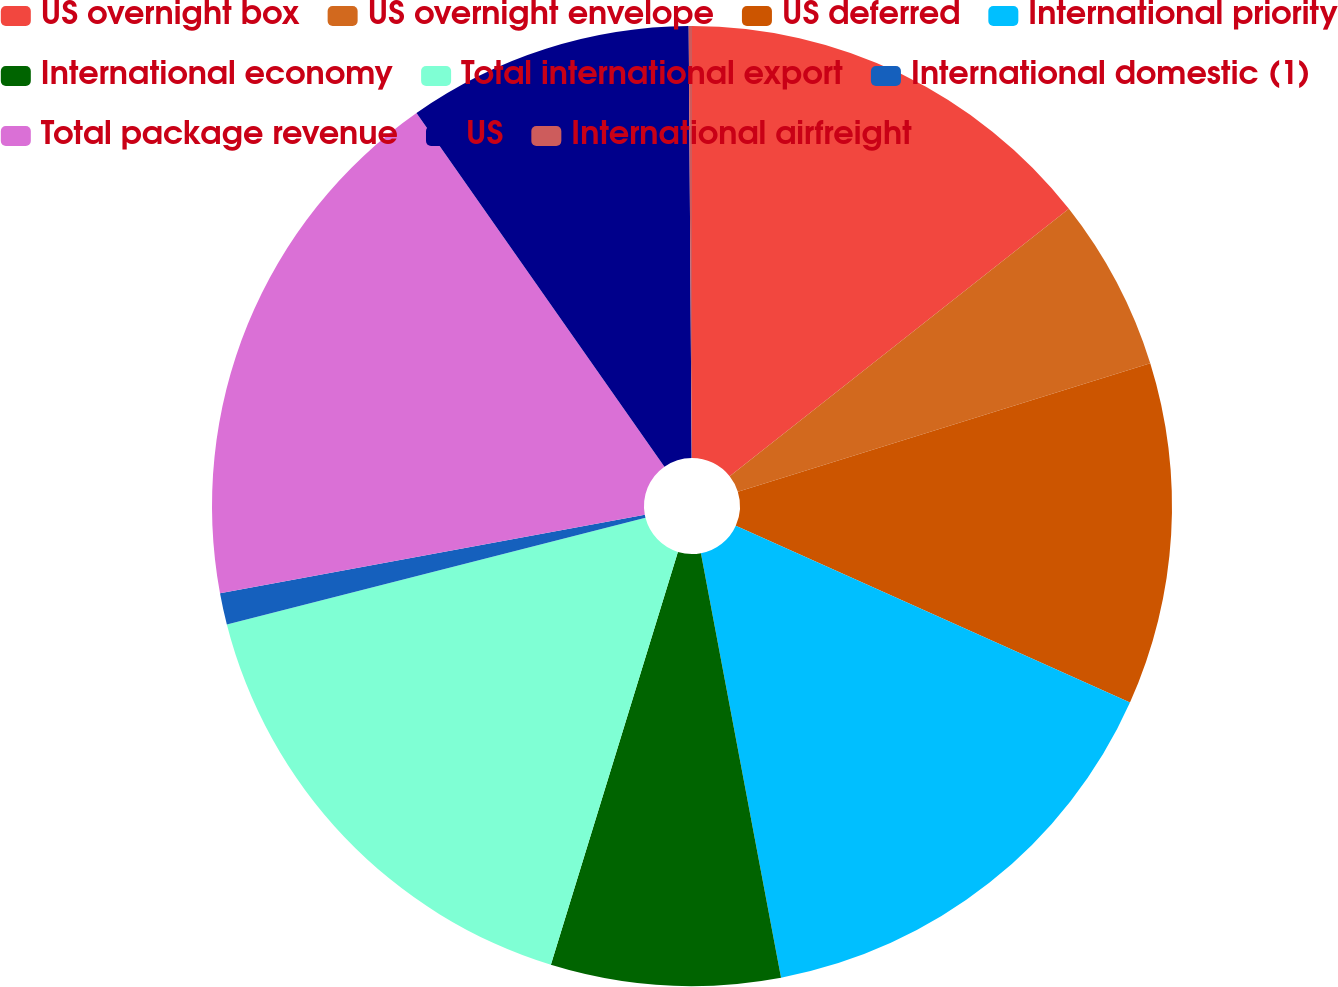Convert chart. <chart><loc_0><loc_0><loc_500><loc_500><pie_chart><fcel>US overnight box<fcel>US overnight envelope<fcel>US deferred<fcel>International priority<fcel>International economy<fcel>Total international export<fcel>International domestic (1)<fcel>Total package revenue<fcel>US<fcel>International airfreight<nl><fcel>14.37%<fcel>5.82%<fcel>11.52%<fcel>15.32%<fcel>7.72%<fcel>16.28%<fcel>1.06%<fcel>18.18%<fcel>9.62%<fcel>0.11%<nl></chart> 